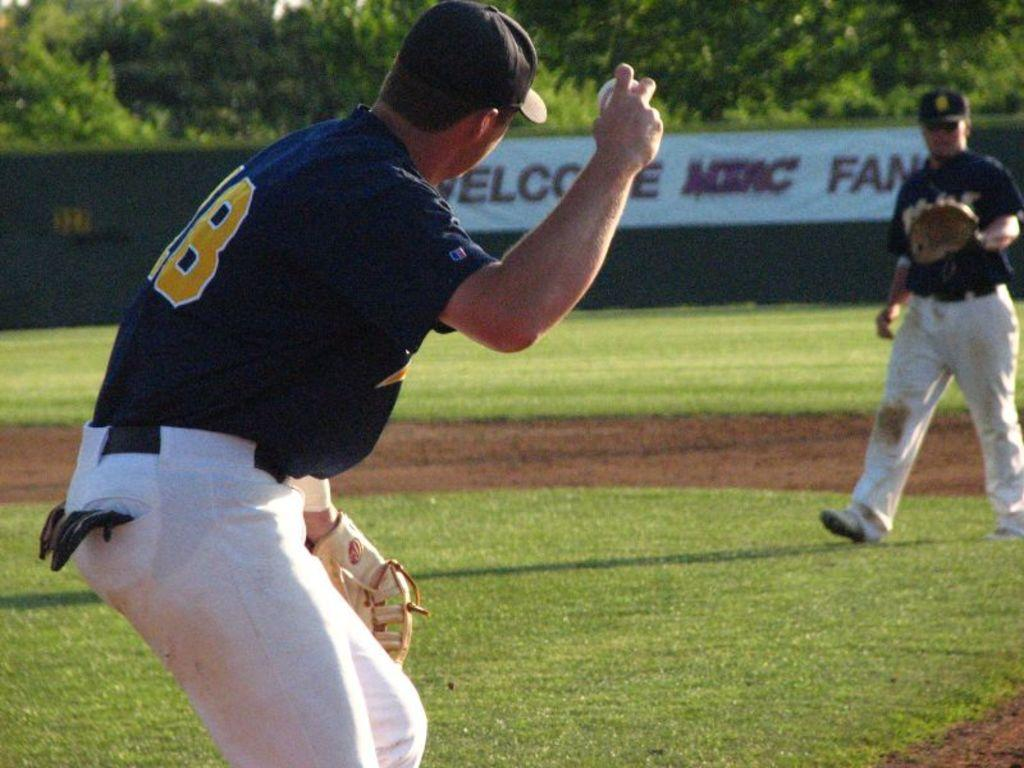<image>
Give a short and clear explanation of the subsequent image. a man throwing a ball that has the word fan in the outfield 